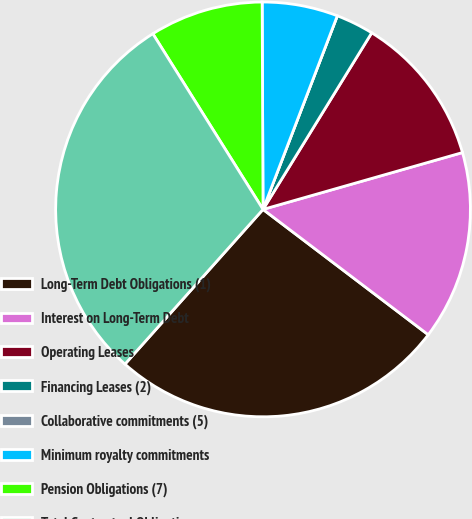<chart> <loc_0><loc_0><loc_500><loc_500><pie_chart><fcel>Long-Term Debt Obligations (1)<fcel>Interest on Long-Term Debt<fcel>Operating Leases<fcel>Financing Leases (2)<fcel>Collaborative commitments (5)<fcel>Minimum royalty commitments<fcel>Pension Obligations (7)<fcel>Total Contractual Obligations<nl><fcel>26.27%<fcel>14.75%<fcel>11.8%<fcel>2.95%<fcel>0.0%<fcel>5.9%<fcel>8.85%<fcel>29.49%<nl></chart> 